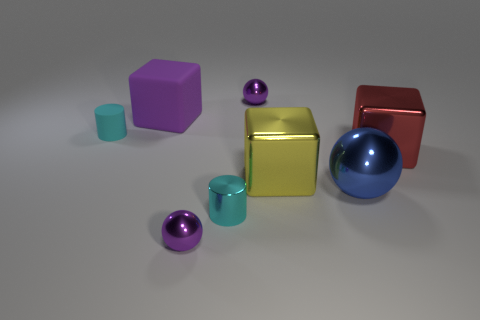Add 1 tiny gray metal things. How many objects exist? 9 Subtract all cubes. How many objects are left? 5 Subtract 0 cyan spheres. How many objects are left? 8 Subtract all cyan rubber things. Subtract all large yellow rubber cylinders. How many objects are left? 7 Add 8 cylinders. How many cylinders are left? 10 Add 2 small cyan objects. How many small cyan objects exist? 4 